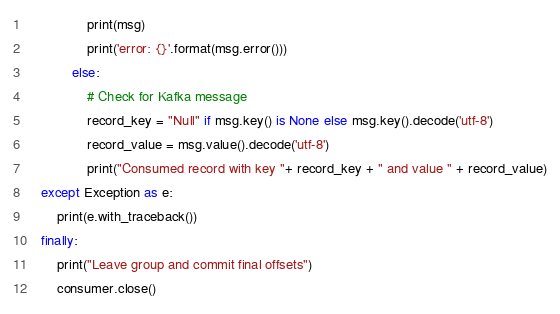Convert code to text. <code><loc_0><loc_0><loc_500><loc_500><_Python_>                print(msg)
                print('error: {}'.format(msg.error()))
            else:
                # Check for Kafka message
                record_key = "Null" if msg.key() is None else msg.key().decode('utf-8')
                record_value = msg.value().decode('utf-8')
                print("Consumed record with key "+ record_key + " and value " + record_value)
    except Exception as e:
        print(e.with_traceback())
    finally:
        print("Leave group and commit final offsets")
        consumer.close()</code> 